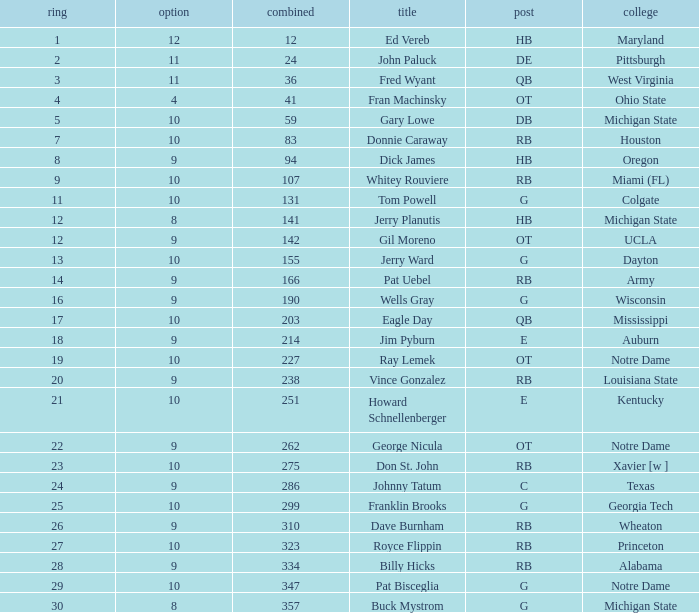What is the overall pick number for a draft pick smaller than 9, named buck mystrom from Michigan State college? 357.0. 